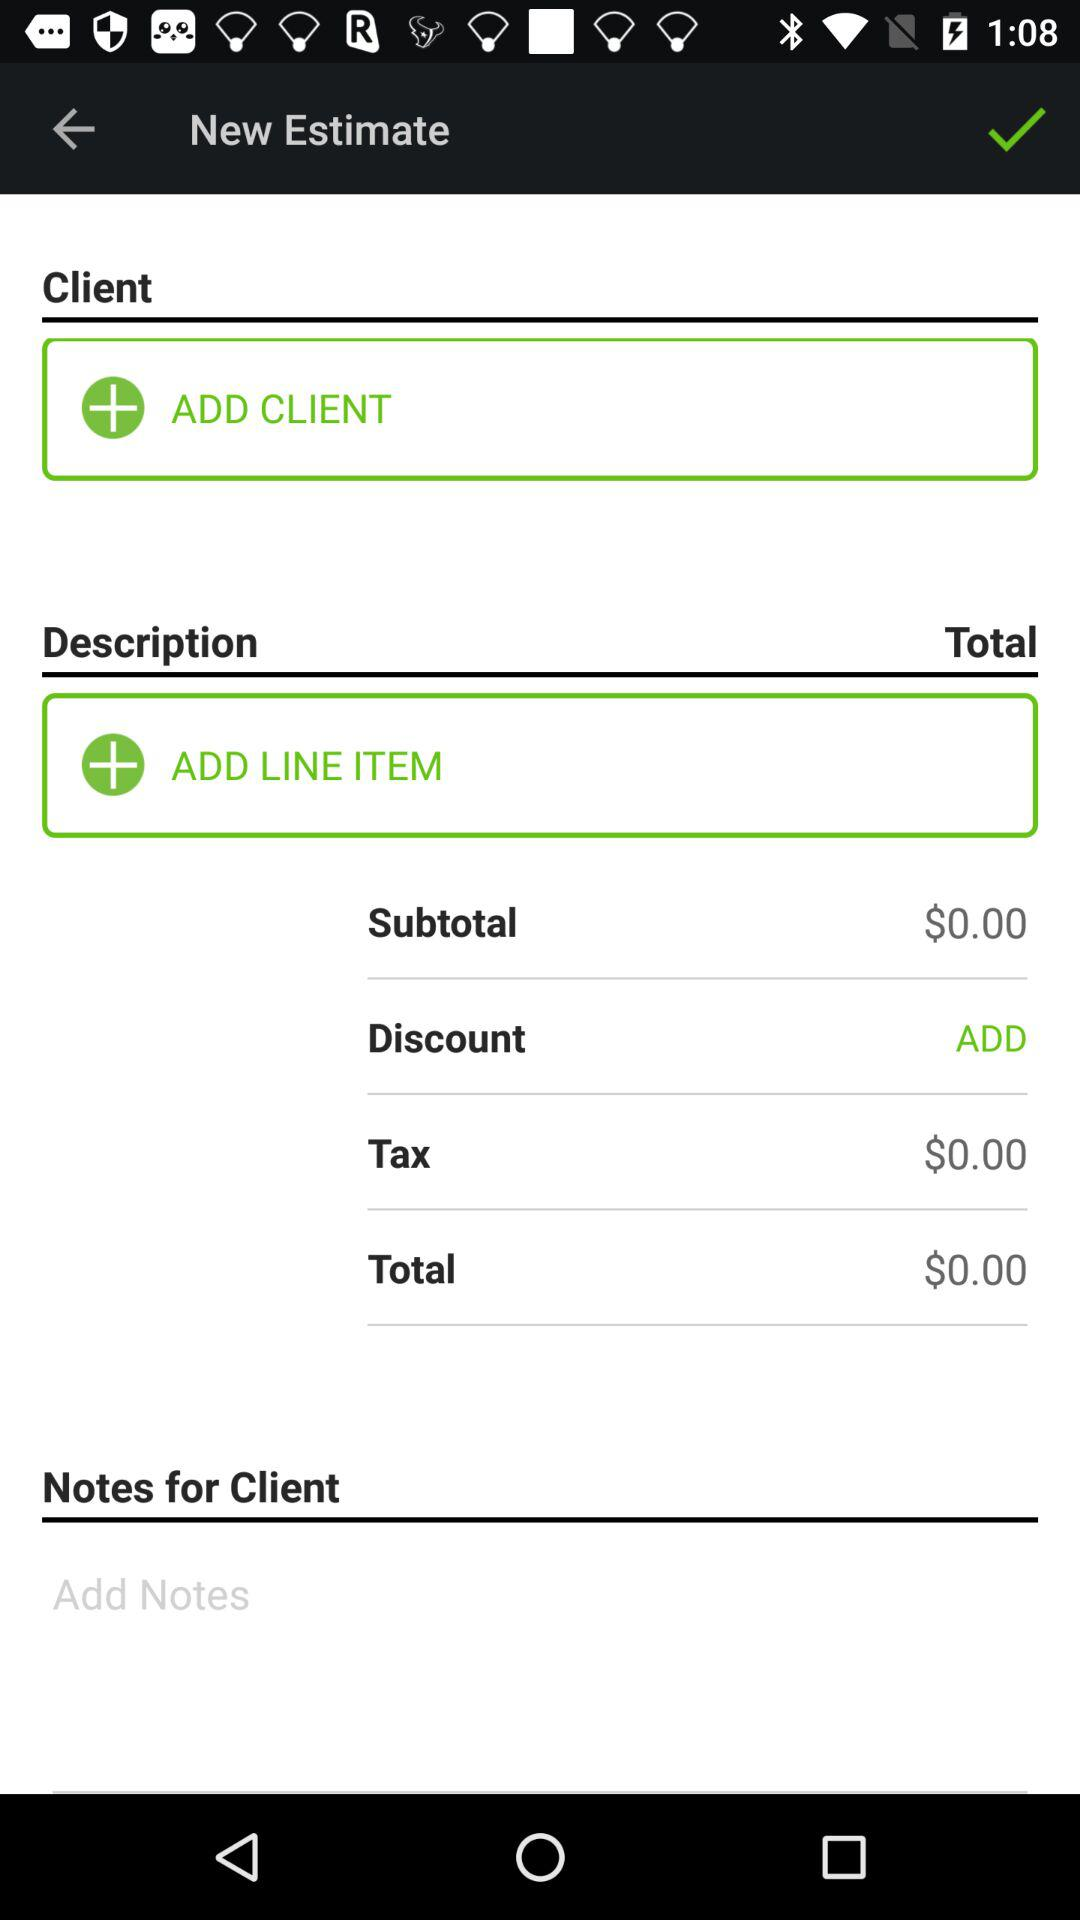What's the subtotal? The subtotal is $0.00. 